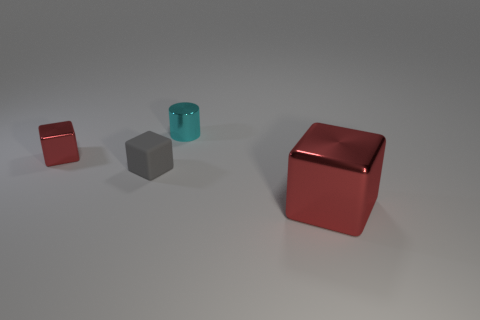What size is the red object to the left of the small gray rubber cube?
Make the answer very short. Small. There is a big thing that is the same shape as the tiny gray thing; what material is it?
Offer a terse response. Metal. The tiny object that is on the left side of the tiny gray rubber block has what shape?
Keep it short and to the point. Cube. How many other objects are the same shape as the gray matte object?
Offer a very short reply. 2. Are there an equal number of small shiny cylinders in front of the large metal cube and rubber cubes that are in front of the gray object?
Provide a short and direct response. Yes. Are there any big blocks that have the same material as the tiny cyan thing?
Offer a terse response. Yes. Do the tiny gray cube and the big red thing have the same material?
Provide a short and direct response. No. What number of cyan things are either shiny cubes or tiny cylinders?
Offer a very short reply. 1. Are there more cubes behind the cylinder than small yellow blocks?
Ensure brevity in your answer.  No. Is there another metal object that has the same color as the big shiny object?
Your answer should be very brief. Yes. 